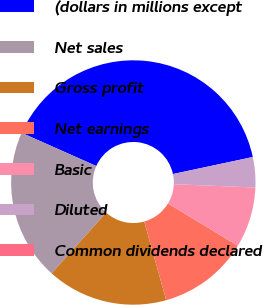<chart> <loc_0><loc_0><loc_500><loc_500><pie_chart><fcel>(dollars in millions except<fcel>Net sales<fcel>Gross profit<fcel>Net earnings<fcel>Basic<fcel>Diluted<fcel>Common dividends declared<nl><fcel>39.99%<fcel>20.0%<fcel>16.0%<fcel>12.0%<fcel>8.0%<fcel>4.0%<fcel>0.0%<nl></chart> 